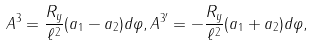Convert formula to latex. <formula><loc_0><loc_0><loc_500><loc_500>A ^ { 3 } = \frac { R _ { y } } { \ell ^ { 2 } } ( a _ { 1 } - a _ { 2 } ) d \varphi , A ^ { 3 ^ { \prime } } = - \frac { R _ { y } } { \ell ^ { 2 } } ( a _ { 1 } + a _ { 2 } ) d \varphi ,</formula> 